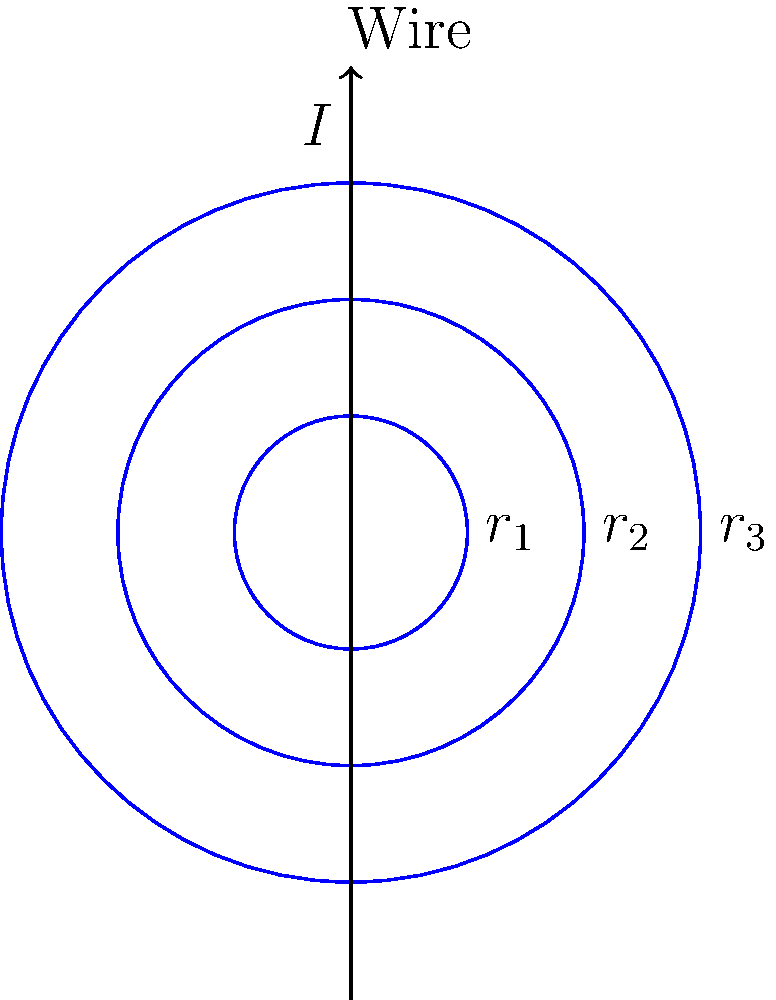As a civil engineer working on the Surasaptak underpass, you encounter an electrical system where a long straight wire carries a current $I$ of 10 A. Three concentric circular paths with radii $r_1 = 2$ cm, $r_2 = 4$ cm, and $r_3 = 6$ cm surround the wire. Calculate the ratio of magnetic field strengths $B_1 : B_2 : B_3$ at these three paths. To solve this problem, we'll use Ampère's law and the relationship between magnetic field strength and distance from a current-carrying wire. Let's proceed step-by-step:

1) According to Ampère's law, the magnetic field strength $B$ at a distance $r$ from a long straight wire carrying current $I$ is given by:

   $$B = \frac{\mu_0 I}{2\pi r}$$

   where $\mu_0$ is the permeability of free space.

2) The magnetic field strength is inversely proportional to the distance from the wire. We can express this as:

   $$B \propto \frac{1}{r}$$

3) For the three circular paths, we have:

   $B_1 \propto \frac{1}{r_1}$, $B_2 \propto \frac{1}{r_2}$, $B_3 \propto \frac{1}{r_3}$

4) To find the ratio, we need to compare these values:

   $B_1 : B_2 : B_3 = \frac{1}{r_1} : \frac{1}{r_2} : \frac{1}{r_3}$

5) Substituting the given radii:

   $B_1 : B_2 : B_3 = \frac{1}{2} : \frac{1}{4} : \frac{1}{6}$

6) To simplify this ratio, multiply all terms by 12 (the LCM of 2, 4, and 6):

   $B_1 : B_2 : B_3 = 6 : 3 : 2$

Thus, the ratio of magnetic field strengths at the three circular paths is 6:3:2.
Answer: 6:3:2 